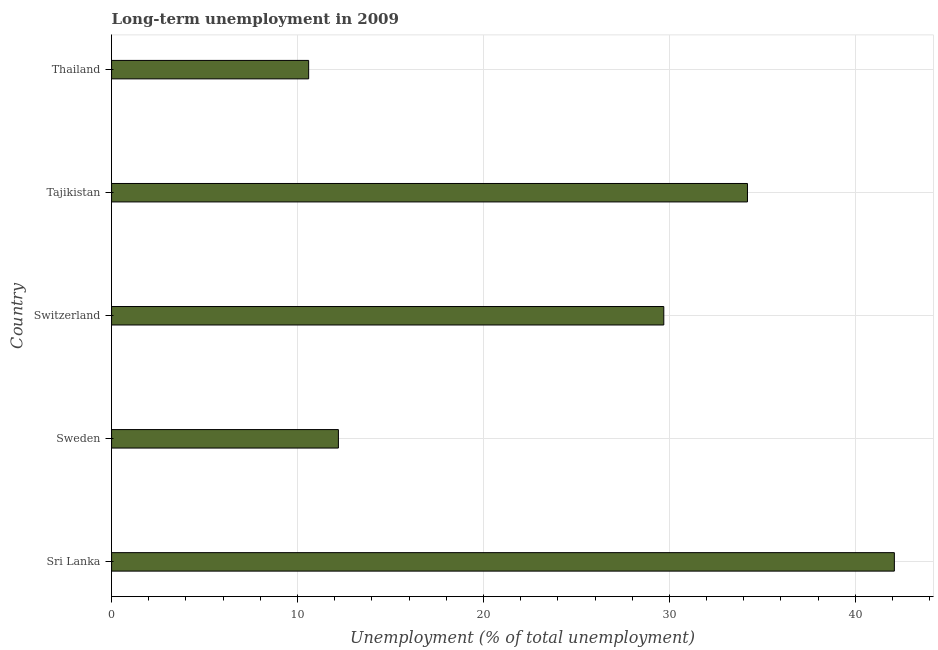Does the graph contain any zero values?
Your response must be concise. No. What is the title of the graph?
Provide a succinct answer. Long-term unemployment in 2009. What is the label or title of the X-axis?
Provide a short and direct response. Unemployment (% of total unemployment). What is the long-term unemployment in Sweden?
Offer a very short reply. 12.2. Across all countries, what is the maximum long-term unemployment?
Offer a terse response. 42.1. Across all countries, what is the minimum long-term unemployment?
Your answer should be compact. 10.6. In which country was the long-term unemployment maximum?
Make the answer very short. Sri Lanka. In which country was the long-term unemployment minimum?
Offer a very short reply. Thailand. What is the sum of the long-term unemployment?
Offer a terse response. 128.8. What is the difference between the long-term unemployment in Sri Lanka and Thailand?
Provide a short and direct response. 31.5. What is the average long-term unemployment per country?
Offer a very short reply. 25.76. What is the median long-term unemployment?
Your response must be concise. 29.7. What is the ratio of the long-term unemployment in Sri Lanka to that in Sweden?
Provide a short and direct response. 3.45. What is the difference between the highest and the second highest long-term unemployment?
Your answer should be very brief. 7.9. What is the difference between the highest and the lowest long-term unemployment?
Keep it short and to the point. 31.5. In how many countries, is the long-term unemployment greater than the average long-term unemployment taken over all countries?
Provide a succinct answer. 3. How many bars are there?
Keep it short and to the point. 5. Are all the bars in the graph horizontal?
Make the answer very short. Yes. How many countries are there in the graph?
Give a very brief answer. 5. What is the difference between two consecutive major ticks on the X-axis?
Offer a terse response. 10. Are the values on the major ticks of X-axis written in scientific E-notation?
Offer a terse response. No. What is the Unemployment (% of total unemployment) of Sri Lanka?
Provide a short and direct response. 42.1. What is the Unemployment (% of total unemployment) of Sweden?
Your response must be concise. 12.2. What is the Unemployment (% of total unemployment) of Switzerland?
Your answer should be compact. 29.7. What is the Unemployment (% of total unemployment) of Tajikistan?
Your answer should be very brief. 34.2. What is the Unemployment (% of total unemployment) of Thailand?
Your response must be concise. 10.6. What is the difference between the Unemployment (% of total unemployment) in Sri Lanka and Sweden?
Make the answer very short. 29.9. What is the difference between the Unemployment (% of total unemployment) in Sri Lanka and Thailand?
Give a very brief answer. 31.5. What is the difference between the Unemployment (% of total unemployment) in Sweden and Switzerland?
Provide a succinct answer. -17.5. What is the difference between the Unemployment (% of total unemployment) in Sweden and Tajikistan?
Provide a short and direct response. -22. What is the difference between the Unemployment (% of total unemployment) in Tajikistan and Thailand?
Provide a succinct answer. 23.6. What is the ratio of the Unemployment (% of total unemployment) in Sri Lanka to that in Sweden?
Your answer should be very brief. 3.45. What is the ratio of the Unemployment (% of total unemployment) in Sri Lanka to that in Switzerland?
Ensure brevity in your answer.  1.42. What is the ratio of the Unemployment (% of total unemployment) in Sri Lanka to that in Tajikistan?
Ensure brevity in your answer.  1.23. What is the ratio of the Unemployment (% of total unemployment) in Sri Lanka to that in Thailand?
Offer a terse response. 3.97. What is the ratio of the Unemployment (% of total unemployment) in Sweden to that in Switzerland?
Make the answer very short. 0.41. What is the ratio of the Unemployment (% of total unemployment) in Sweden to that in Tajikistan?
Give a very brief answer. 0.36. What is the ratio of the Unemployment (% of total unemployment) in Sweden to that in Thailand?
Give a very brief answer. 1.15. What is the ratio of the Unemployment (% of total unemployment) in Switzerland to that in Tajikistan?
Offer a terse response. 0.87. What is the ratio of the Unemployment (% of total unemployment) in Switzerland to that in Thailand?
Keep it short and to the point. 2.8. What is the ratio of the Unemployment (% of total unemployment) in Tajikistan to that in Thailand?
Make the answer very short. 3.23. 